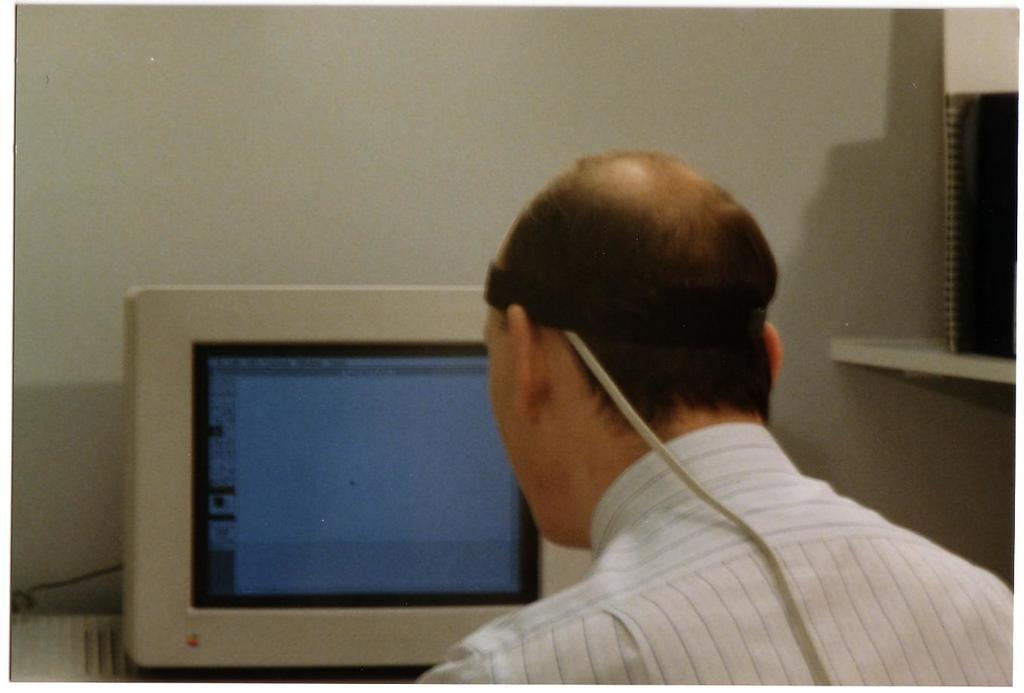Who or what is present in the image? There is a person in the image. What can be seen on the wall in the image? There is a monitor in the image. What is the background of the image made of? There is a wall in the image. What is used for storage in the image? There is a shelf in the image. What is placed on the shelf? An object is placed on the shelf. What religious guide is the person holding in the image? There is no religious guide present in the image; it only shows a person, a monitor, a wall, a shelf, and an object placed on the shelf. 